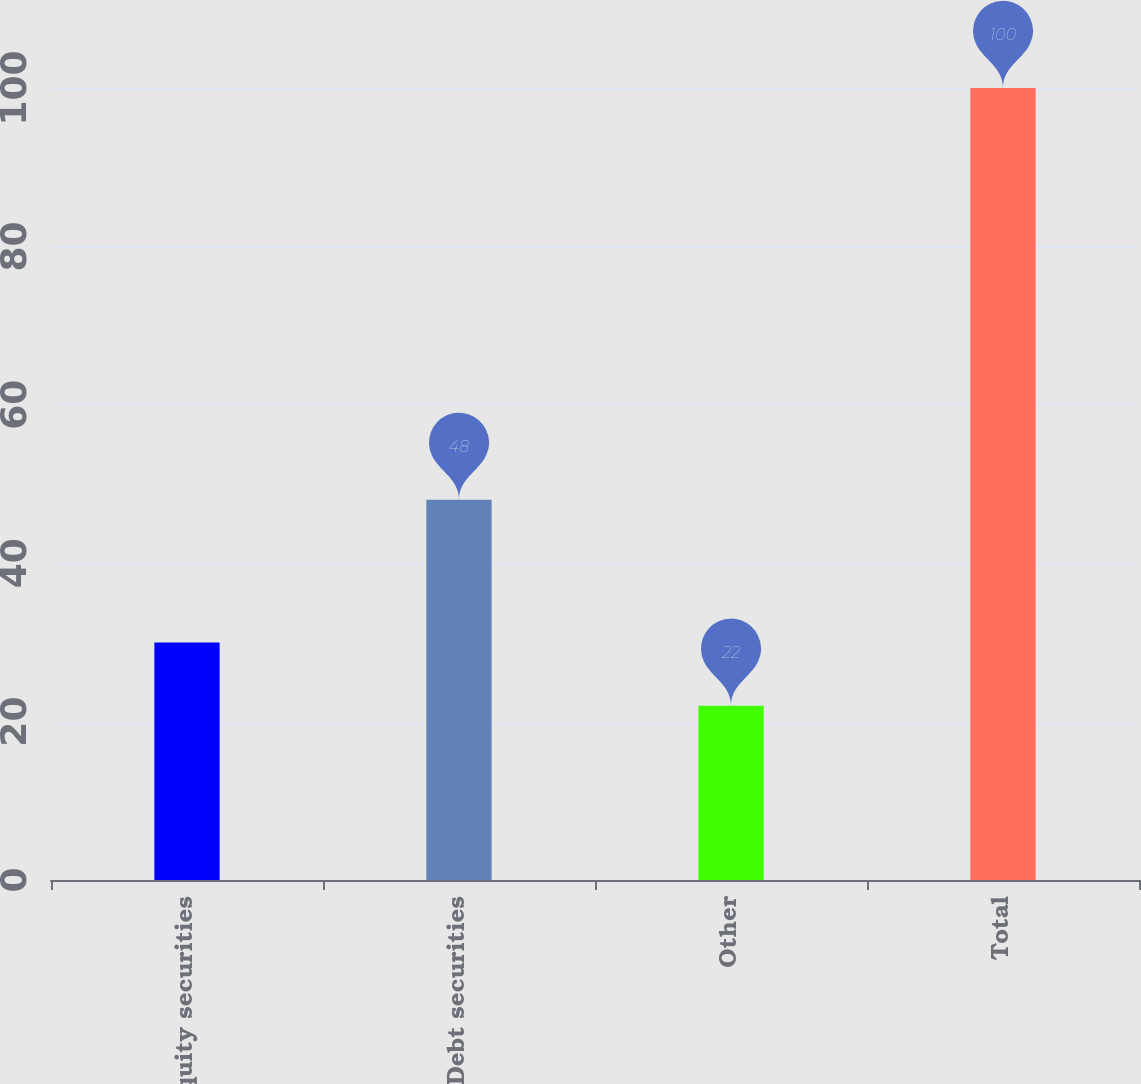Convert chart to OTSL. <chart><loc_0><loc_0><loc_500><loc_500><bar_chart><fcel>Equity securities<fcel>Debt securities<fcel>Other<fcel>Total<nl><fcel>30<fcel>48<fcel>22<fcel>100<nl></chart> 